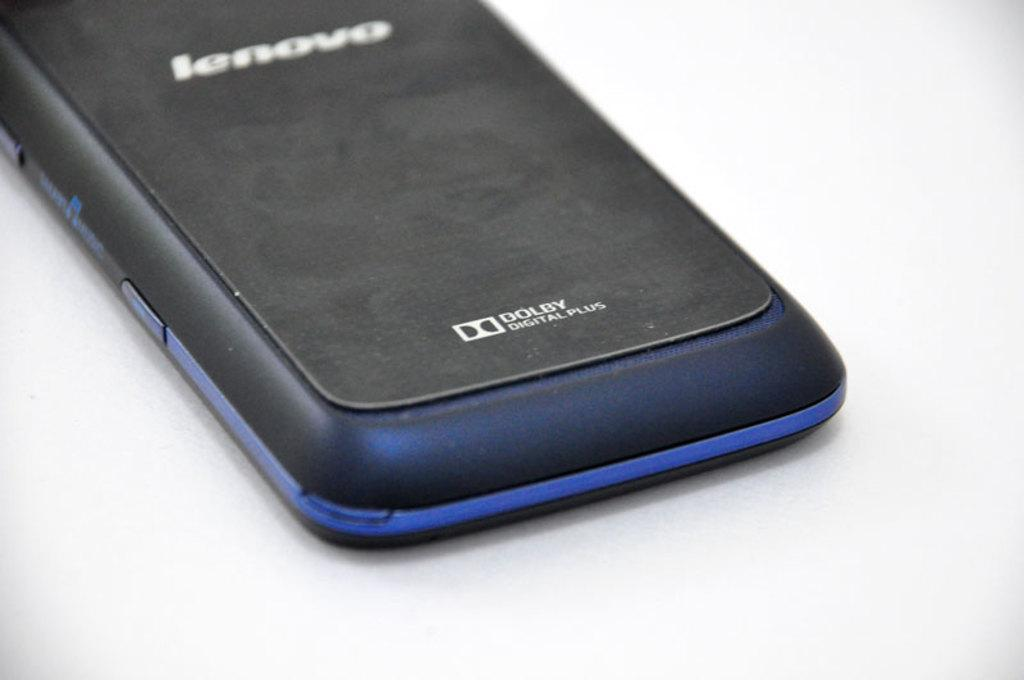Provide a one-sentence caption for the provided image. The back side of a blue and black Lenovo cell phone. 